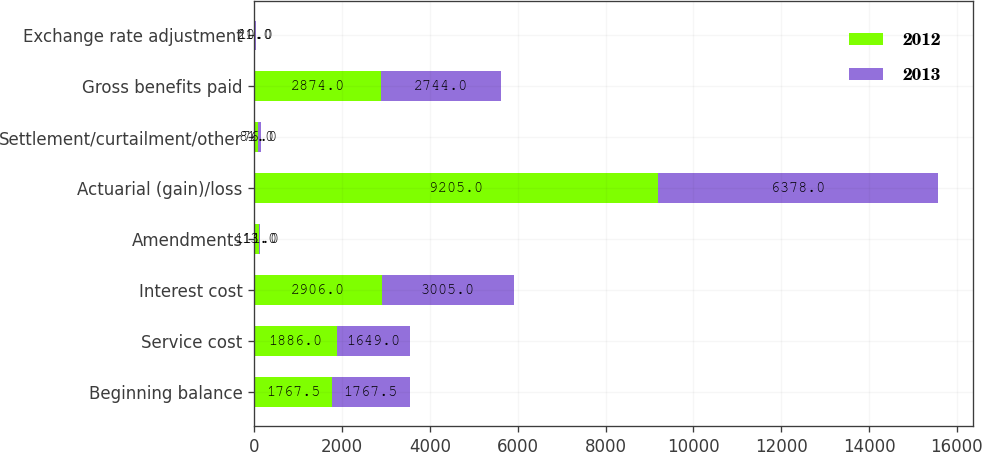<chart> <loc_0><loc_0><loc_500><loc_500><stacked_bar_chart><ecel><fcel>Beginning balance<fcel>Service cost<fcel>Interest cost<fcel>Amendments<fcel>Actuarial (gain)/loss<fcel>Settlement/curtailment/other<fcel>Gross benefits paid<fcel>Exchange rate adjustment<nl><fcel>2012<fcel>1767.5<fcel>1886<fcel>2906<fcel>111<fcel>9205<fcel>81<fcel>2874<fcel>21<nl><fcel>2013<fcel>1767.5<fcel>1649<fcel>3005<fcel>13<fcel>6378<fcel>76<fcel>2744<fcel>10<nl></chart> 